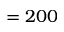Convert formula to latex. <formula><loc_0><loc_0><loc_500><loc_500>= 2 0 0</formula> 